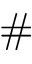<formula> <loc_0><loc_0><loc_500><loc_500>\#</formula> 